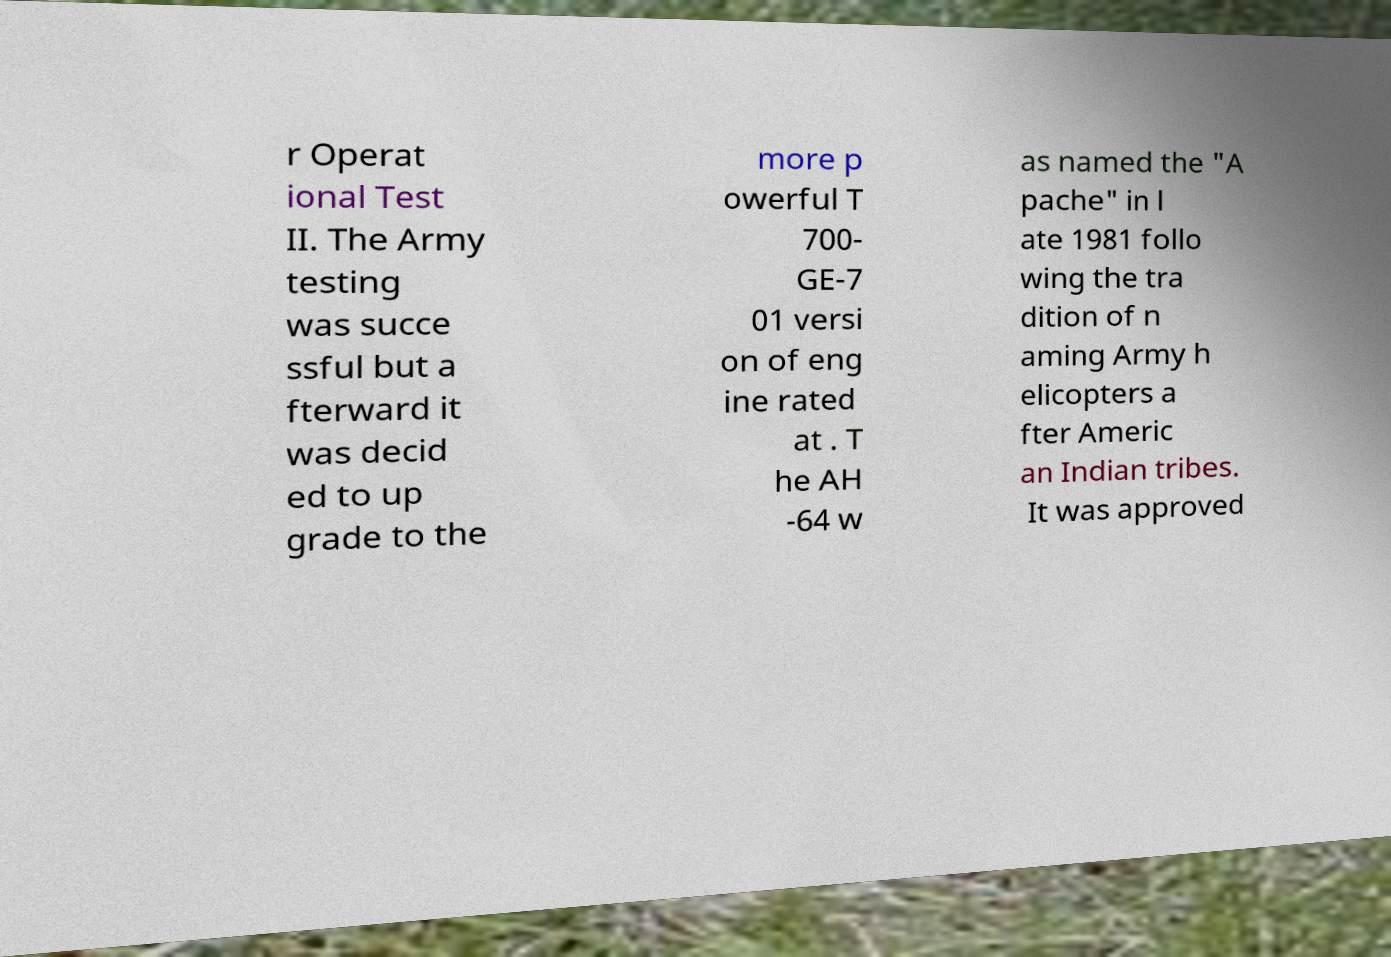Can you accurately transcribe the text from the provided image for me? r Operat ional Test II. The Army testing was succe ssful but a fterward it was decid ed to up grade to the more p owerful T 700- GE-7 01 versi on of eng ine rated at . T he AH -64 w as named the "A pache" in l ate 1981 follo wing the tra dition of n aming Army h elicopters a fter Americ an Indian tribes. It was approved 